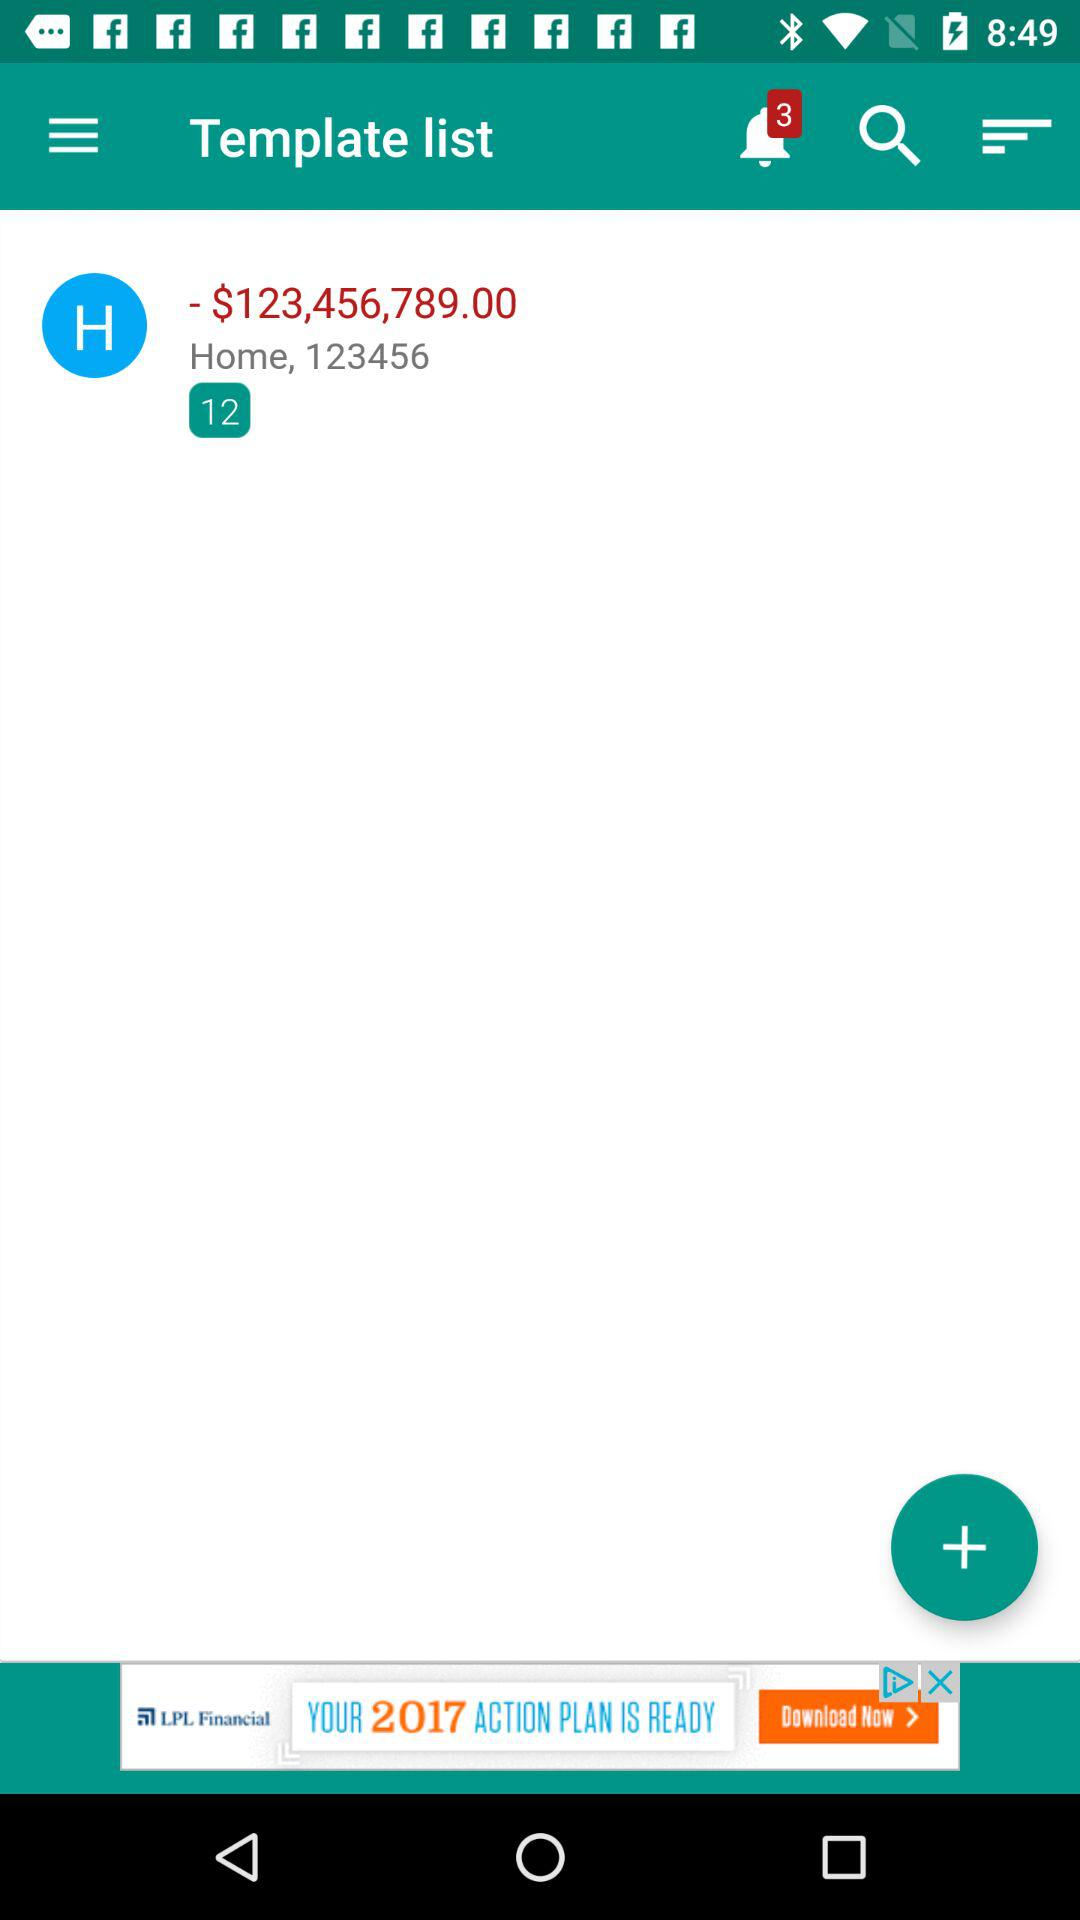Where is the home located?
When the provided information is insufficient, respond with <no answer>. <no answer> 